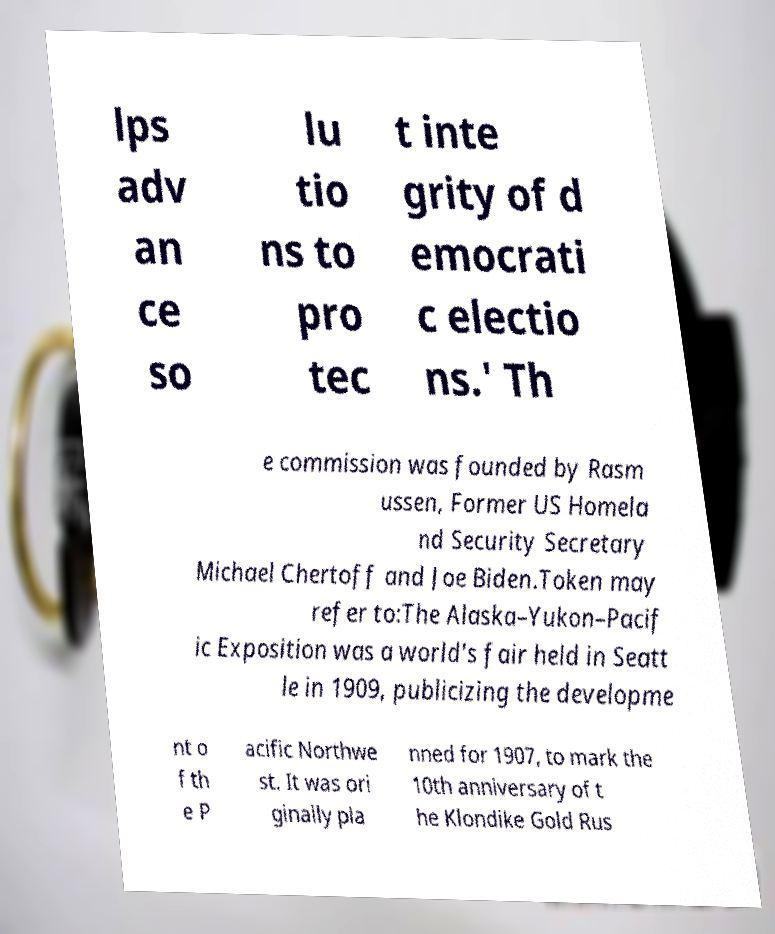What messages or text are displayed in this image? I need them in a readable, typed format. lps adv an ce so lu tio ns to pro tec t inte grity of d emocrati c electio ns.' Th e commission was founded by Rasm ussen, Former US Homela nd Security Secretary Michael Chertoff and Joe Biden.Token may refer to:The Alaska–Yukon–Pacif ic Exposition was a world's fair held in Seatt le in 1909, publicizing the developme nt o f th e P acific Northwe st. It was ori ginally pla nned for 1907, to mark the 10th anniversary of t he Klondike Gold Rus 